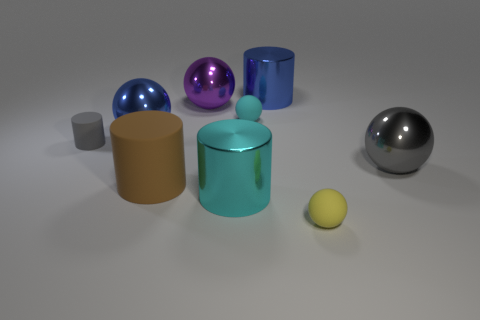The matte cylinder that is the same size as the cyan metal cylinder is what color?
Give a very brief answer. Brown. What is the shape of the thing that is both on the right side of the tiny cyan matte thing and in front of the big gray metal object?
Your answer should be very brief. Sphere. What is the size of the rubber ball behind the large shiny object that is to the right of the small yellow sphere?
Offer a very short reply. Small. How many other cylinders are the same color as the tiny cylinder?
Your answer should be very brief. 0. How many other objects are there of the same size as the cyan ball?
Offer a terse response. 2. There is a metallic thing that is both right of the big cyan cylinder and behind the large blue metal ball; how big is it?
Provide a succinct answer. Large. How many cyan things are the same shape as the large gray thing?
Give a very brief answer. 1. What is the cyan cylinder made of?
Provide a succinct answer. Metal. Do the big gray thing and the large purple metallic object have the same shape?
Your response must be concise. Yes. Is there a big yellow cylinder made of the same material as the big purple thing?
Provide a short and direct response. No. 